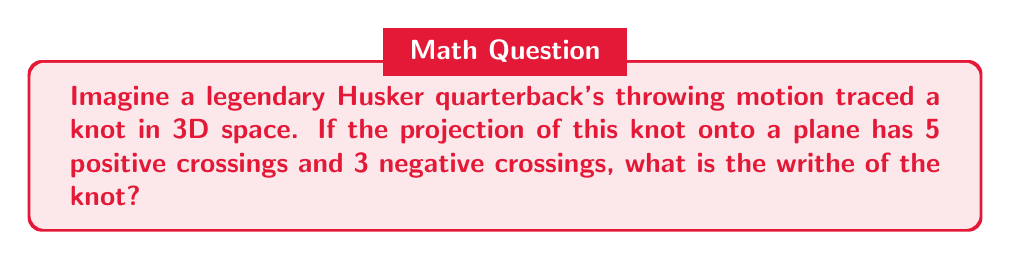Give your solution to this math problem. Let's approach this step-by-step:

1) In knot theory, the writhe of a knot is a measure of its "twistedness" when projected onto a plane.

2) The writhe is calculated by summing the signs of all crossings in the knot's projection.

3) In this case, we have:
   - 5 positive crossings
   - 3 negative crossings

4) Each positive crossing contributes +1 to the writhe.
   Each negative crossing contributes -1 to the writhe.

5) So, we can calculate the writhe as follows:

   $$ \text{Writhe} = (\text{Number of positive crossings}) - (\text{Number of negative crossings}) $$

6) Substituting our values:

   $$ \text{Writhe} = 5 - 3 $$

7) Simplifying:

   $$ \text{Writhe} = 2 $$

Therefore, the writhe of the knot inspired by the quarterback's throwing motion is 2.
Answer: 2 